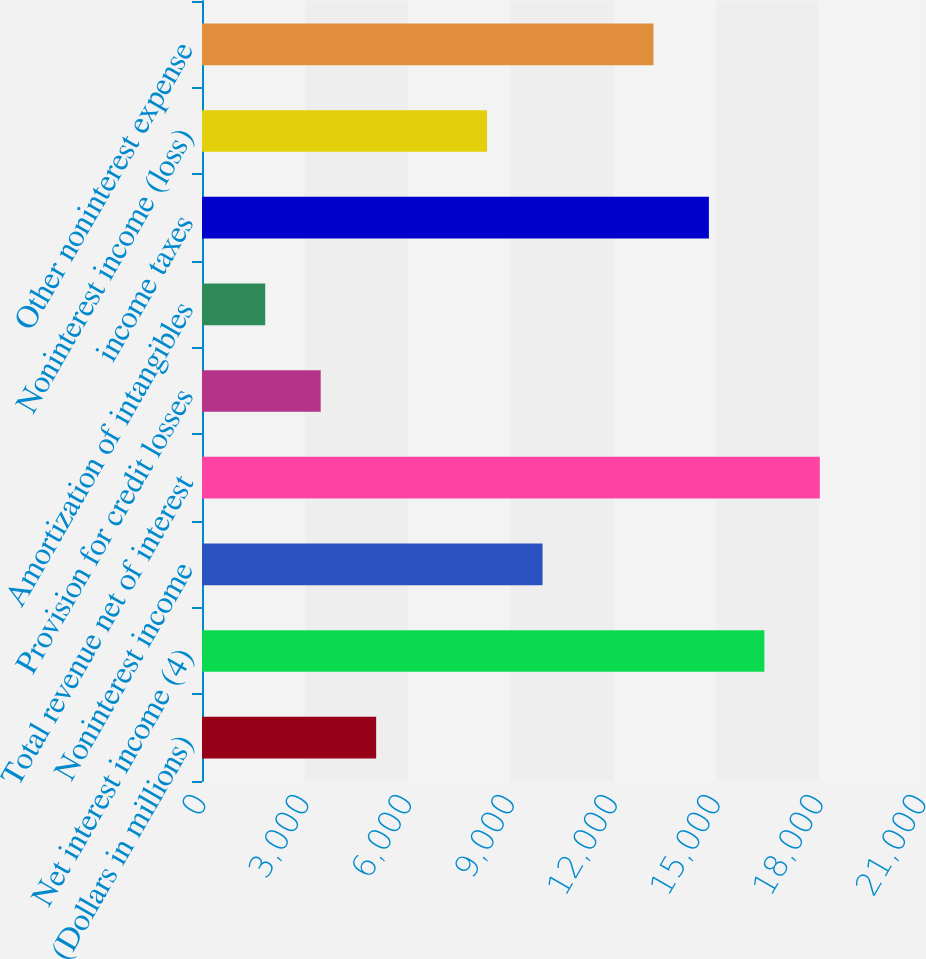<chart> <loc_0><loc_0><loc_500><loc_500><bar_chart><fcel>(Dollars in millions)<fcel>Net interest income (4)<fcel>Noninterest income<fcel>Total revenue net of interest<fcel>Provision for credit losses<fcel>Amortization of intangibles<fcel>income taxes<fcel>Noninterest income (loss)<fcel>Other noninterest expense<nl><fcel>5079.5<fcel>16402<fcel>9932<fcel>18019.5<fcel>3462<fcel>1844.5<fcel>14784.5<fcel>8314.5<fcel>13167<nl></chart> 